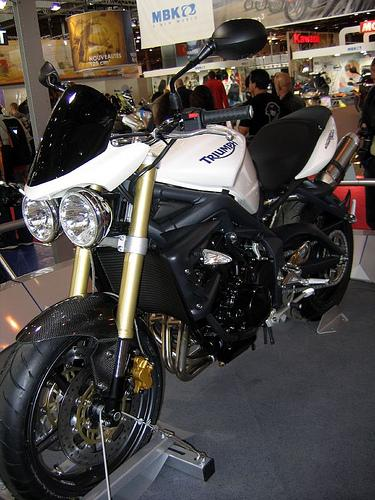What kind of bike is this? Please explain your reasoning. motorbike. The other options wouldn't apply in this image. 